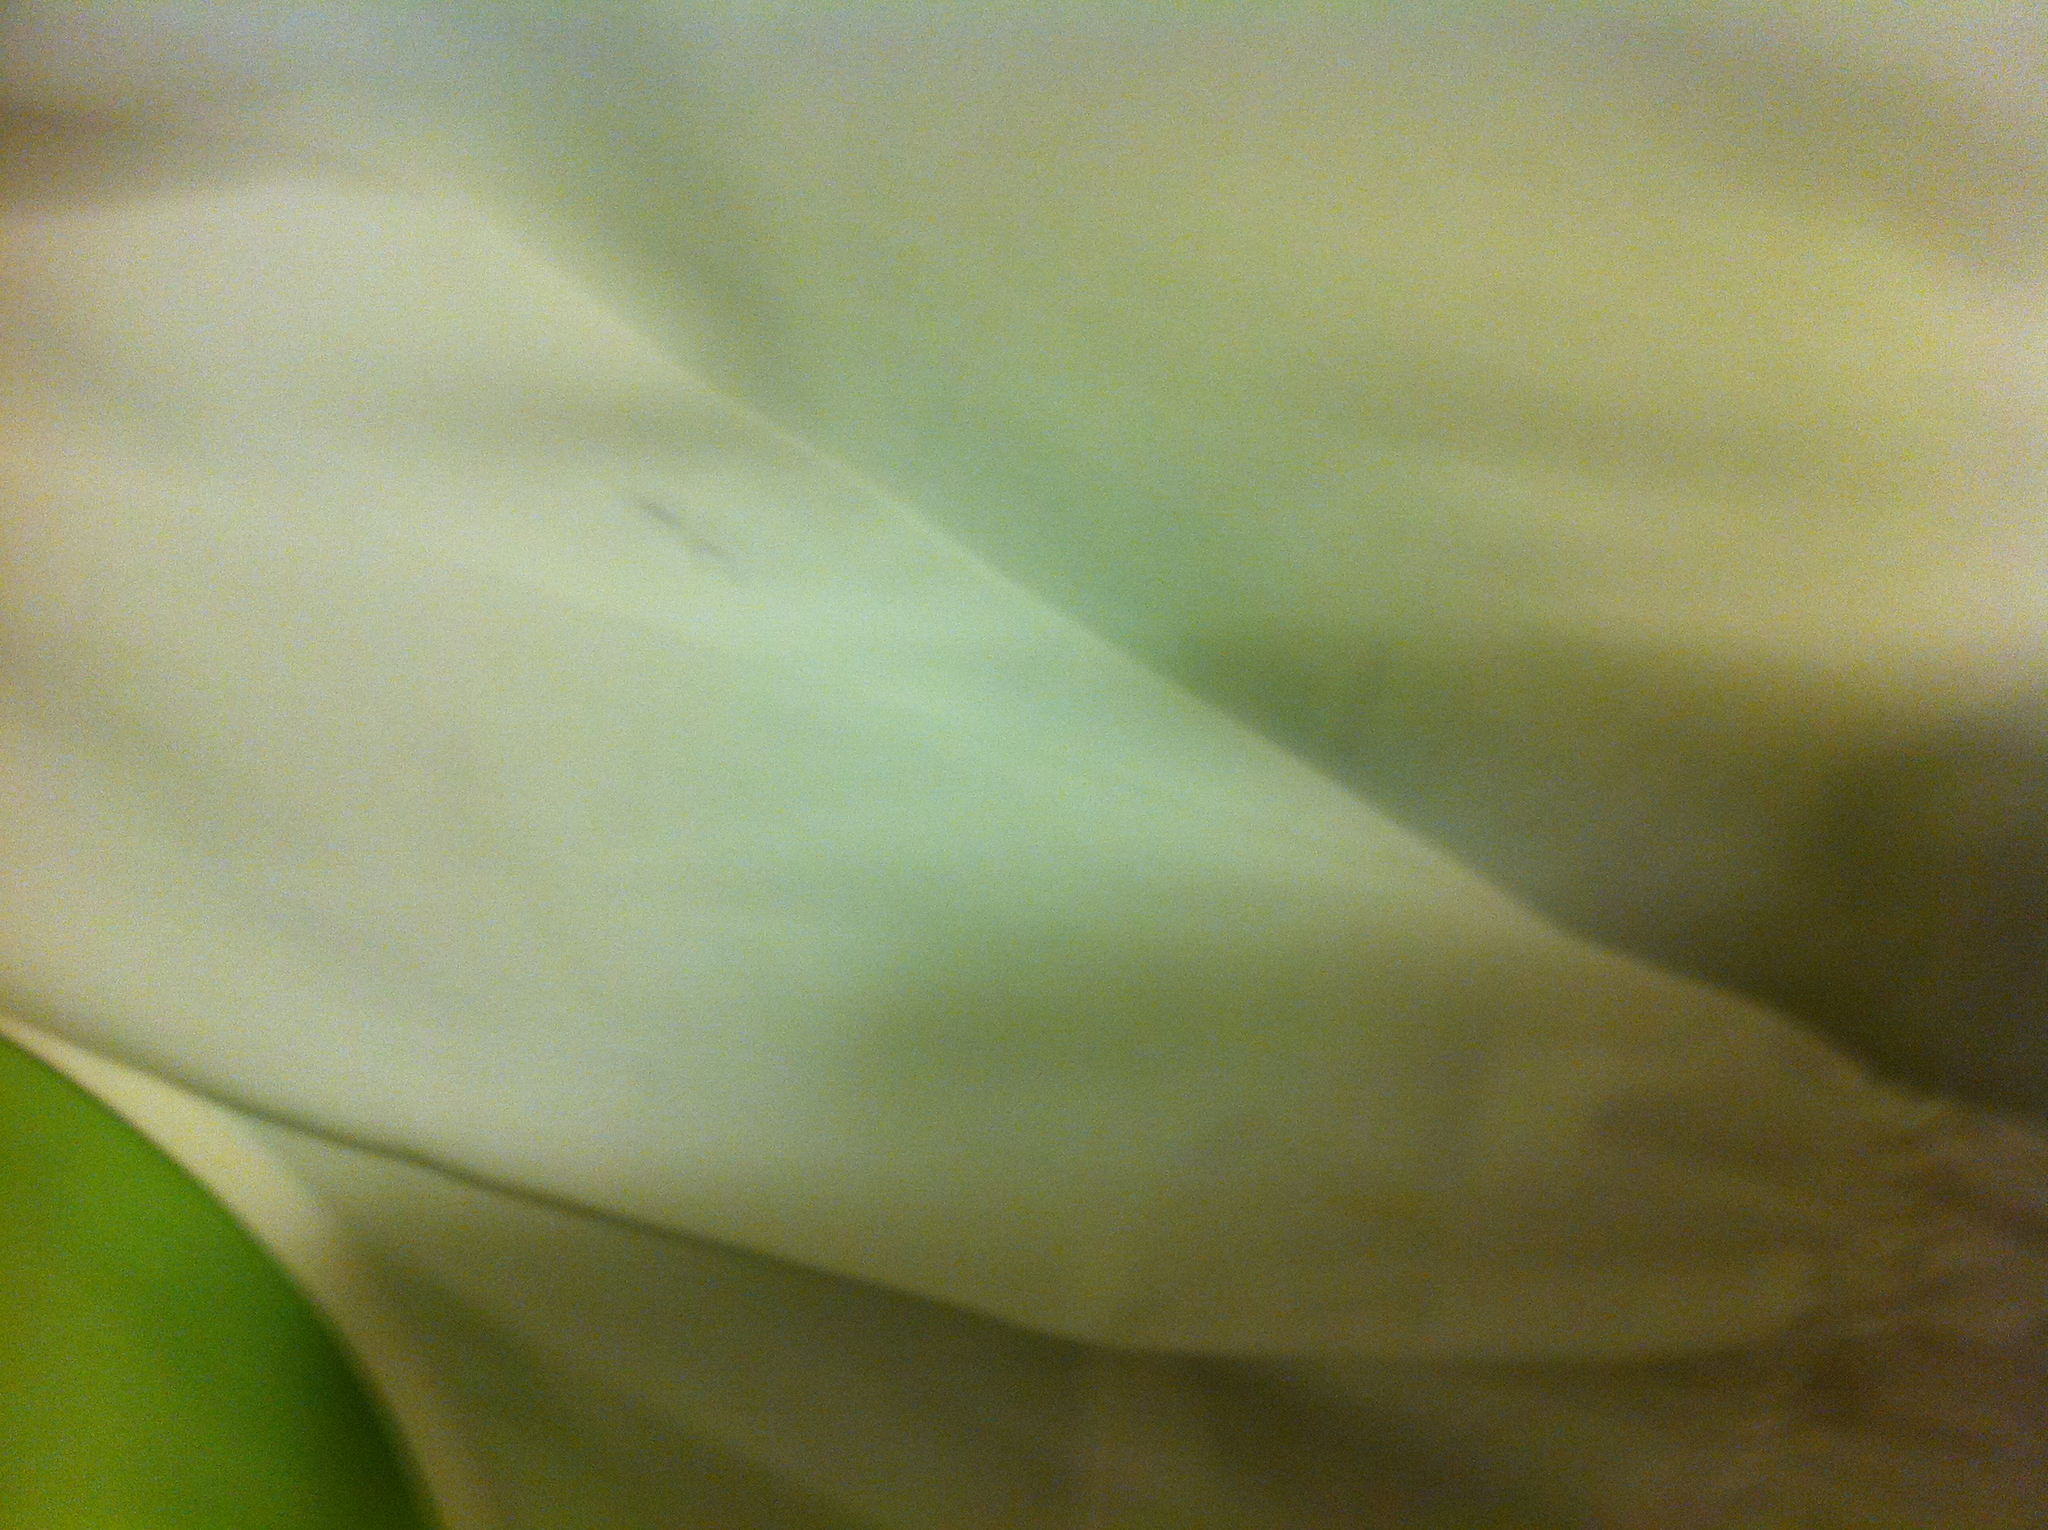What color shirt is this? from Vizwiz white 